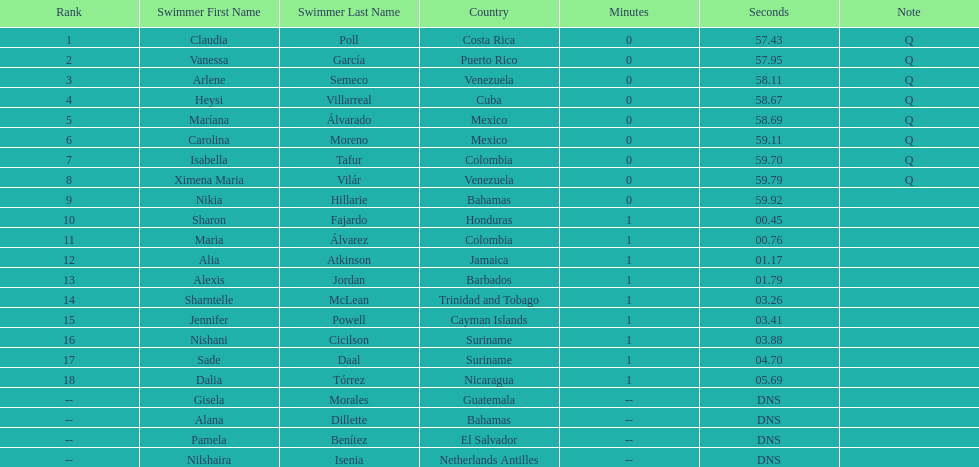Who was the only cuban to finish in the top eight? Heysi Villarreal. 